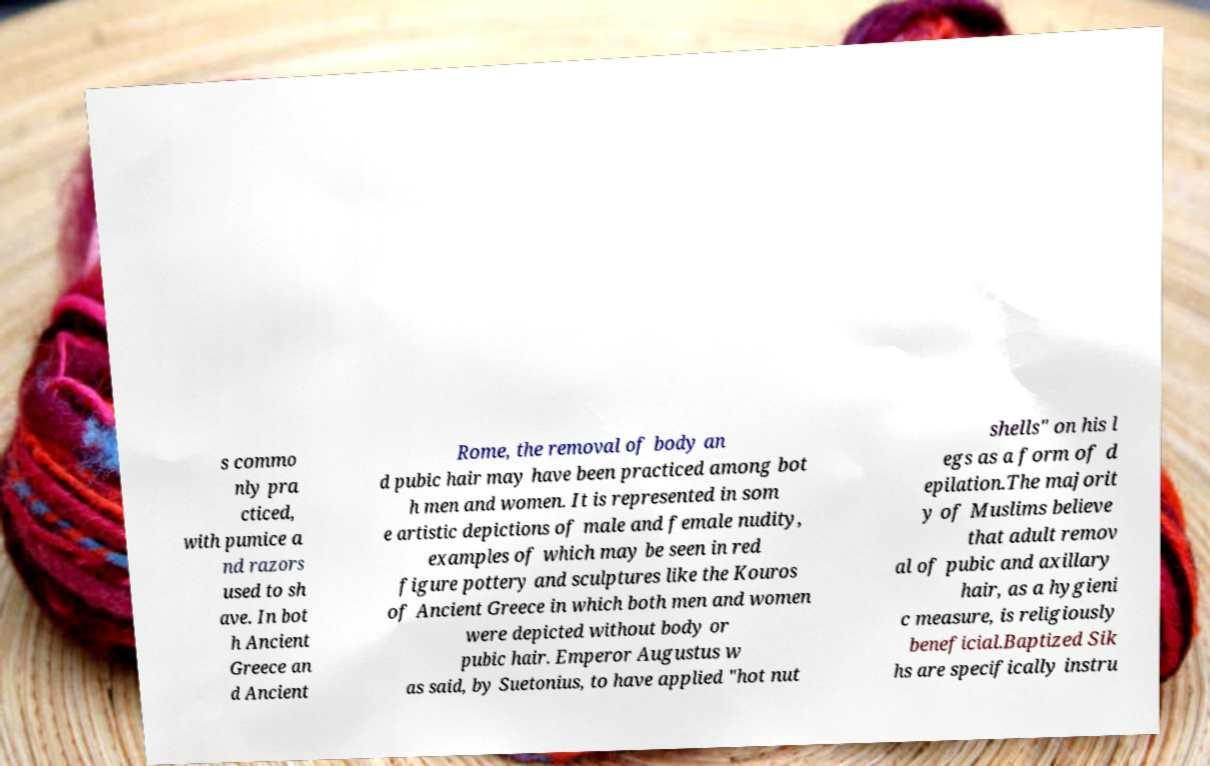Please read and relay the text visible in this image. What does it say? s commo nly pra cticed, with pumice a nd razors used to sh ave. In bot h Ancient Greece an d Ancient Rome, the removal of body an d pubic hair may have been practiced among bot h men and women. It is represented in som e artistic depictions of male and female nudity, examples of which may be seen in red figure pottery and sculptures like the Kouros of Ancient Greece in which both men and women were depicted without body or pubic hair. Emperor Augustus w as said, by Suetonius, to have applied "hot nut shells" on his l egs as a form of d epilation.The majorit y of Muslims believe that adult remov al of pubic and axillary hair, as a hygieni c measure, is religiously beneficial.Baptized Sik hs are specifically instru 